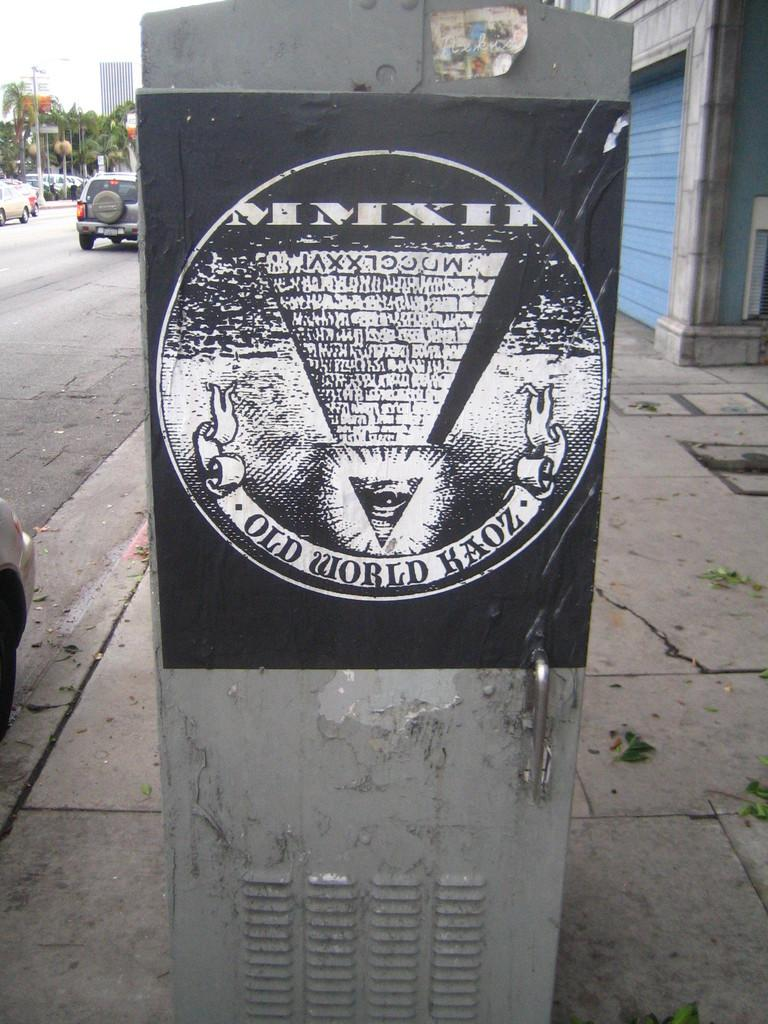<image>
Render a clear and concise summary of the photo. A black sign for Old World Kaoz is on the side of a metal locker on the street. 